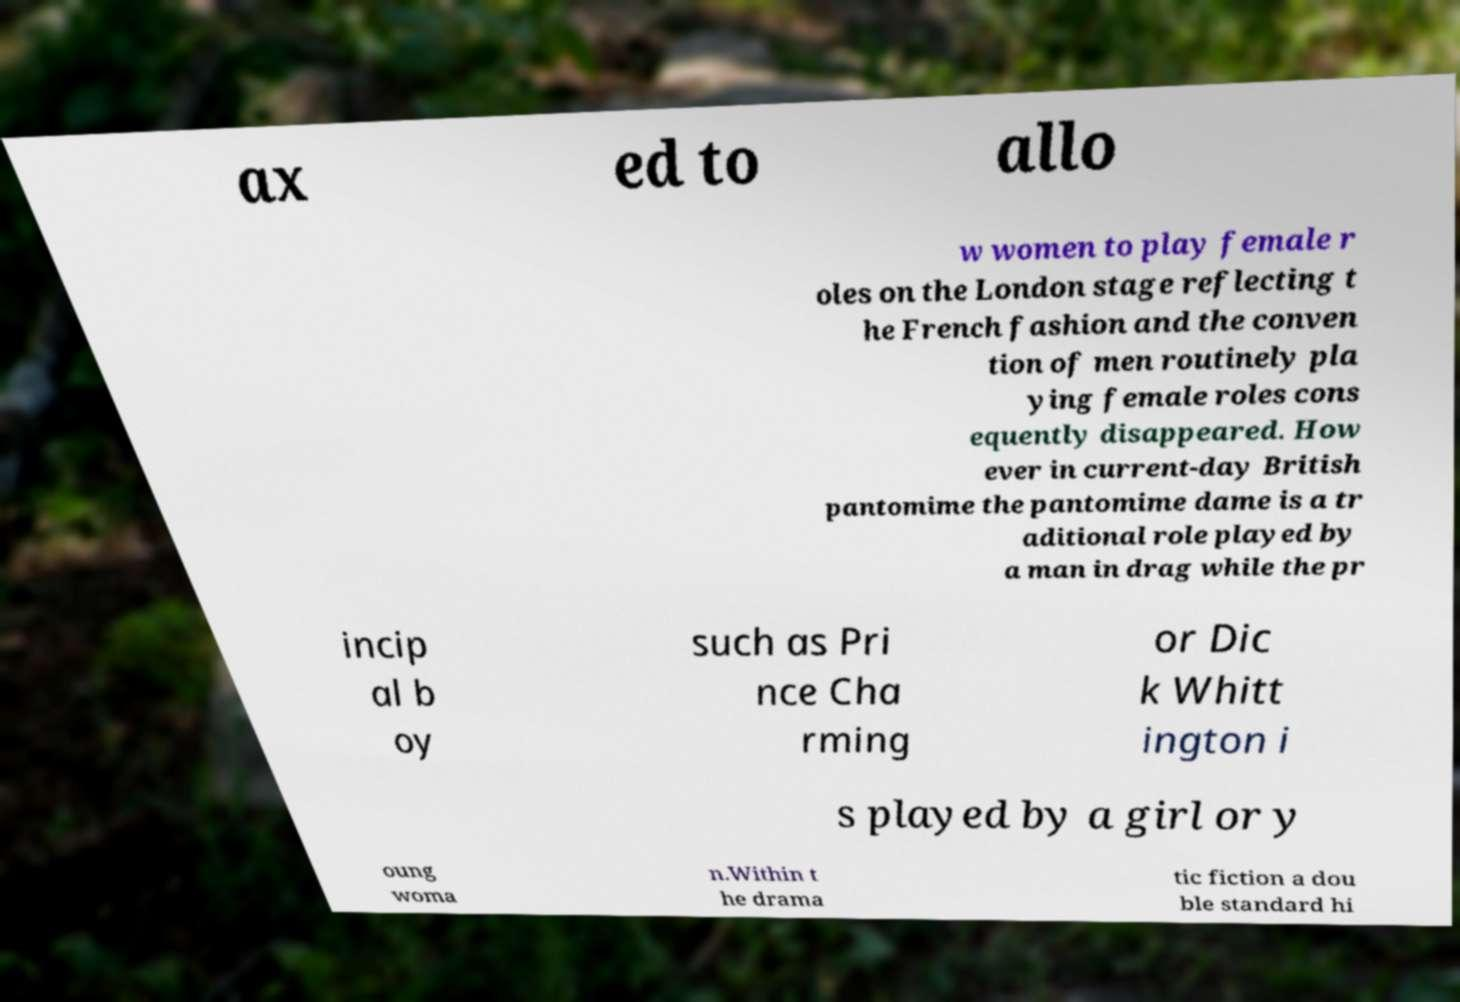Can you accurately transcribe the text from the provided image for me? ax ed to allo w women to play female r oles on the London stage reflecting t he French fashion and the conven tion of men routinely pla ying female roles cons equently disappeared. How ever in current-day British pantomime the pantomime dame is a tr aditional role played by a man in drag while the pr incip al b oy such as Pri nce Cha rming or Dic k Whitt ington i s played by a girl or y oung woma n.Within t he drama tic fiction a dou ble standard hi 